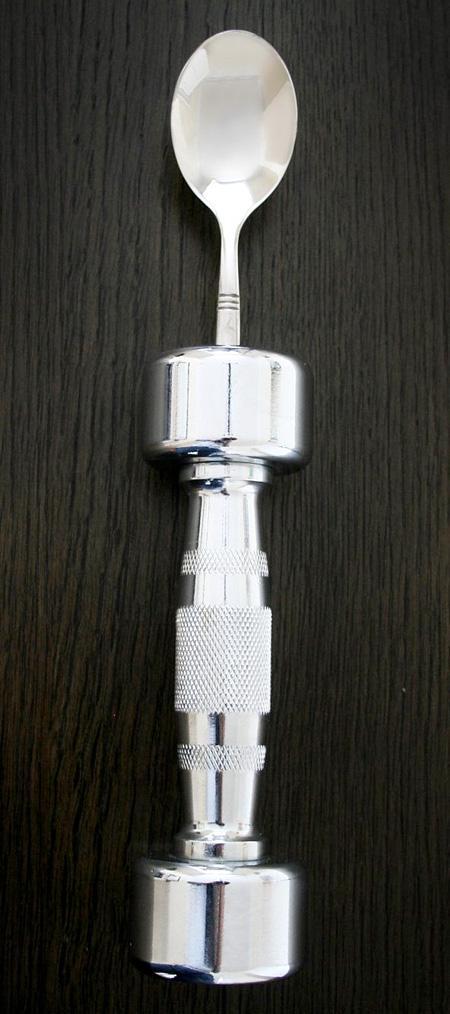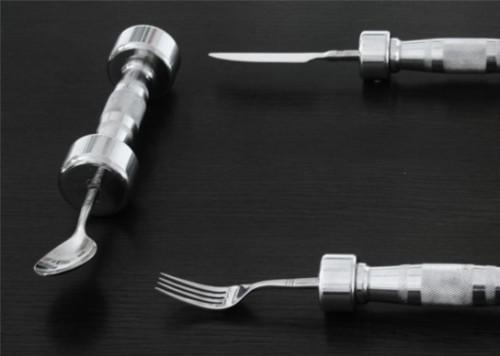The first image is the image on the left, the second image is the image on the right. For the images displayed, is the sentence "There is a knife, fork, and spoon in the image on the right." factually correct? Answer yes or no. Yes. 